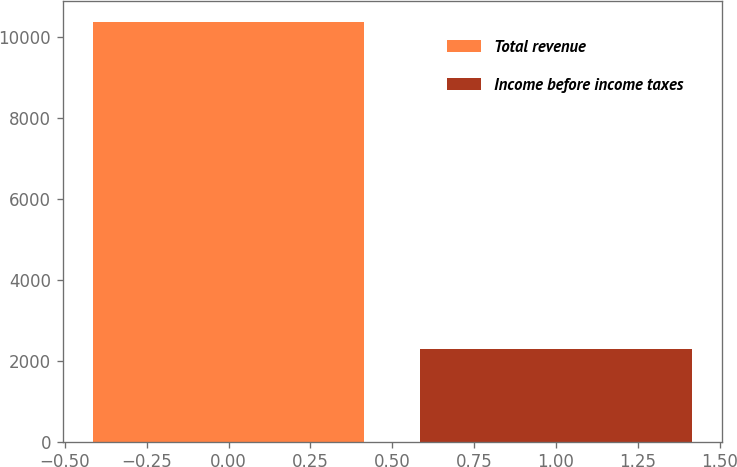Convert chart. <chart><loc_0><loc_0><loc_500><loc_500><bar_chart><fcel>Total revenue<fcel>Income before income taxes<nl><fcel>10360<fcel>2298<nl></chart> 